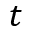<formula> <loc_0><loc_0><loc_500><loc_500>t</formula> 